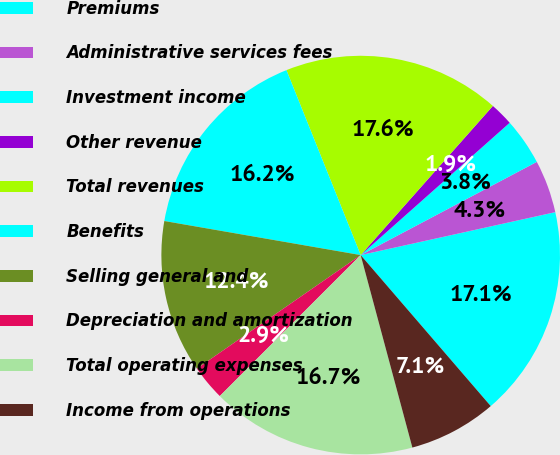<chart> <loc_0><loc_0><loc_500><loc_500><pie_chart><fcel>Premiums<fcel>Administrative services fees<fcel>Investment income<fcel>Other revenue<fcel>Total revenues<fcel>Benefits<fcel>Selling general and<fcel>Depreciation and amortization<fcel>Total operating expenses<fcel>Income from operations<nl><fcel>17.14%<fcel>4.29%<fcel>3.81%<fcel>1.9%<fcel>17.62%<fcel>16.19%<fcel>12.38%<fcel>2.86%<fcel>16.67%<fcel>7.14%<nl></chart> 